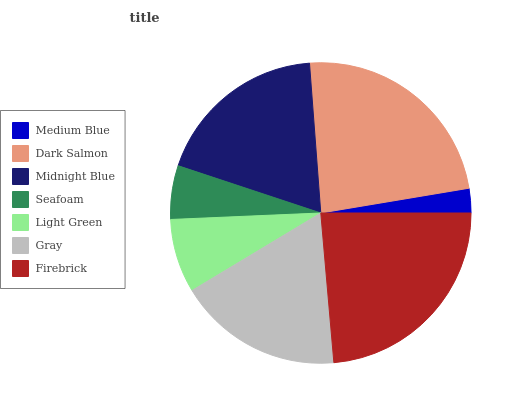Is Medium Blue the minimum?
Answer yes or no. Yes. Is Firebrick the maximum?
Answer yes or no. Yes. Is Dark Salmon the minimum?
Answer yes or no. No. Is Dark Salmon the maximum?
Answer yes or no. No. Is Dark Salmon greater than Medium Blue?
Answer yes or no. Yes. Is Medium Blue less than Dark Salmon?
Answer yes or no. Yes. Is Medium Blue greater than Dark Salmon?
Answer yes or no. No. Is Dark Salmon less than Medium Blue?
Answer yes or no. No. Is Gray the high median?
Answer yes or no. Yes. Is Gray the low median?
Answer yes or no. Yes. Is Firebrick the high median?
Answer yes or no. No. Is Medium Blue the low median?
Answer yes or no. No. 